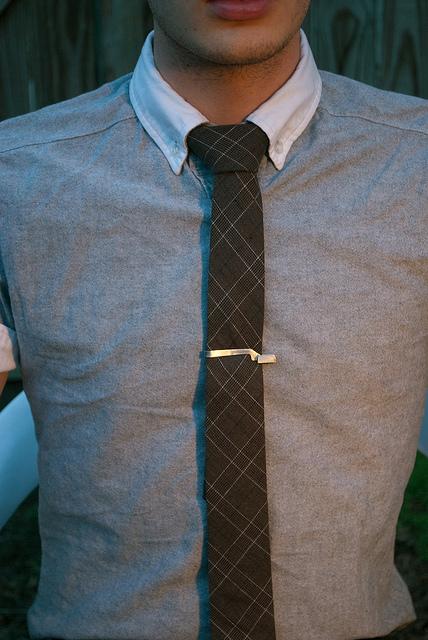What colors is this man's shirt?
Give a very brief answer. Gray. Does the shirt match the tie?
Keep it brief. Yes. What shape is on his neckwear?
Write a very short answer. Rectangular. What color is the tie clip?
Quick response, please. Silver. Is there a rubber band in the picture?
Write a very short answer. No. What is this person wearing around their neck?
Keep it brief. Tie. Is this a man or a woman?
Answer briefly. Man. 